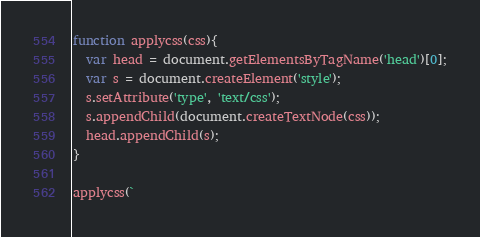<code> <loc_0><loc_0><loc_500><loc_500><_JavaScript_>function applycss(css){
  var head = document.getElementsByTagName('head')[0];
  var s = document.createElement('style');
  s.setAttribute('type', 'text/css');
  s.appendChild(document.createTextNode(css));
  head.appendChild(s);
}

applycss(`</code> 